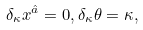<formula> <loc_0><loc_0><loc_500><loc_500>\delta _ { \kappa } x ^ { \hat { a } } = 0 , \delta _ { \kappa } \theta = \kappa ,</formula> 